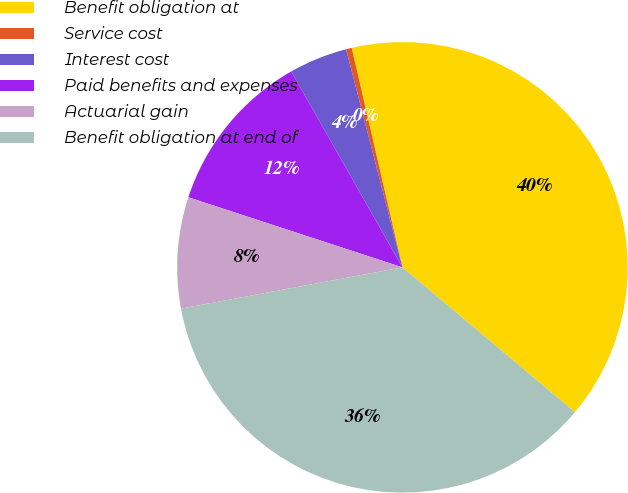Convert chart to OTSL. <chart><loc_0><loc_0><loc_500><loc_500><pie_chart><fcel>Benefit obligation at<fcel>Service cost<fcel>Interest cost<fcel>Paid benefits and expenses<fcel>Actuarial gain<fcel>Benefit obligation at end of<nl><fcel>39.73%<fcel>0.41%<fcel>4.19%<fcel>11.75%<fcel>7.97%<fcel>35.95%<nl></chart> 